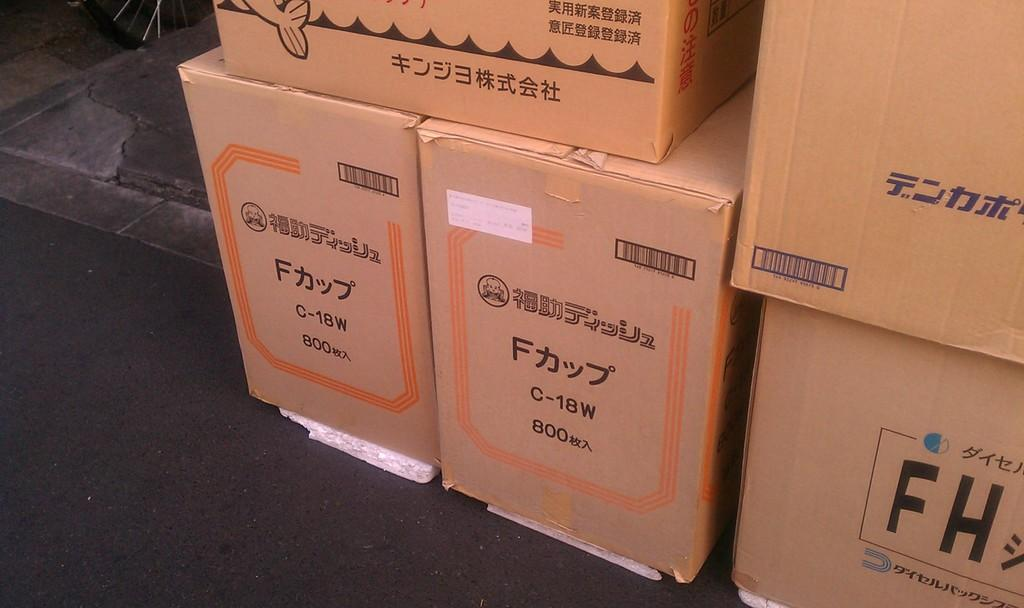What type of objects can be seen in the image? There are cardboard boxes in the image. What is written on the cardboard boxes? There is writing on the cardboard boxes. How many clovers are growing near the cardboard boxes in the image? There are no clovers present in the image; it only features cardboard boxes with writing on them. 